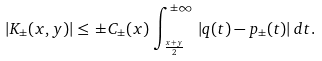<formula> <loc_0><loc_0><loc_500><loc_500>| K _ { \pm } ( x , y ) | \leq \, \pm C _ { \pm } ( x ) \, \int _ { \frac { x + y } { 2 } } ^ { \pm \infty } \, | q ( t ) - p _ { \pm } ( t ) | \, d t .</formula> 